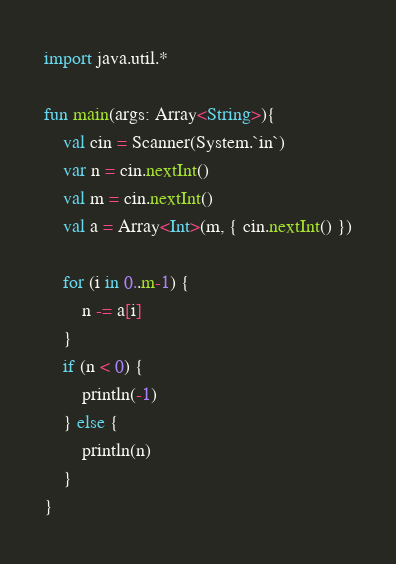<code> <loc_0><loc_0><loc_500><loc_500><_Kotlin_>import java.util.*

fun main(args: Array<String>){
	val cin = Scanner(System.`in`)
    var n = cin.nextInt()
    val m = cin.nextInt()
    val a = Array<Int>(m, { cin.nextInt() })

    for (i in 0..m-1) {
        n -= a[i]
    }
    if (n < 0) {
        println(-1)
    } else {
        println(n)
    }
}</code> 